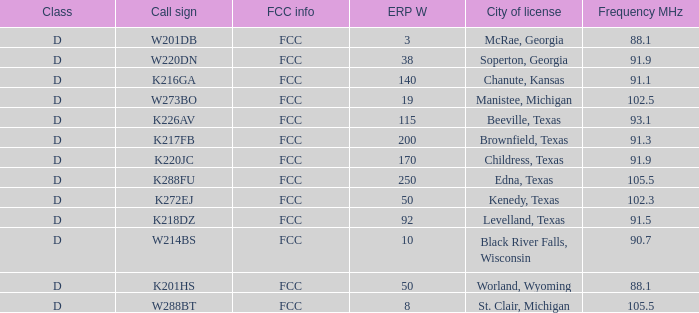What is City of License, when Frequency MHz is less than 102.5? McRae, Georgia, Soperton, Georgia, Chanute, Kansas, Beeville, Texas, Brownfield, Texas, Childress, Texas, Kenedy, Texas, Levelland, Texas, Black River Falls, Wisconsin, Worland, Wyoming. 